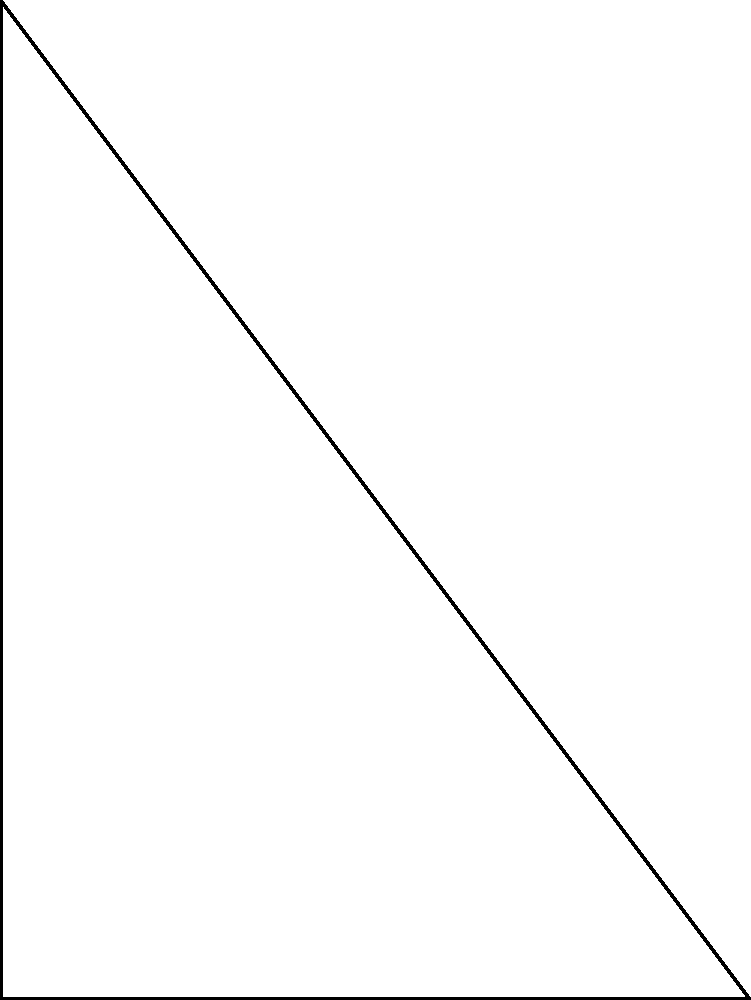In the e-book publishing industry, optimizing page layouts is crucial. Consider a triangular design element with vertices at A(0,0), B(6,0), and C(0,8). Determine if this triangle is right-angled, and if so, which angle is the right angle? To determine if the triangle is right-angled, we'll use the Pythagorean theorem:

1) Calculate the lengths of all sides:
   AB = $\sqrt{(6-0)^2 + (0-0)^2} = 6$
   AC = $\sqrt{(0-0)^2 + (8-0)^2} = 8$
   BC = $\sqrt{(6-0)^2 + (8-0)^2} = \sqrt{36 + 64} = \sqrt{100} = 10$

2) Check if the Pythagorean theorem holds for any combination:
   $AB^2 + AC^2 = 6^2 + 8^2 = 36 + 64 = 100$
   $BC^2 = 10^2 = 100$

3) Since $AB^2 + AC^2 = BC^2$, the triangle is right-angled.

4) The right angle is at vertex A, where the two shorter sides (AB and AC) meet.

This right-angled triangle could represent an optimal corner design for e-book pages, balancing white space and content area.
Answer: Yes, right angle at A 